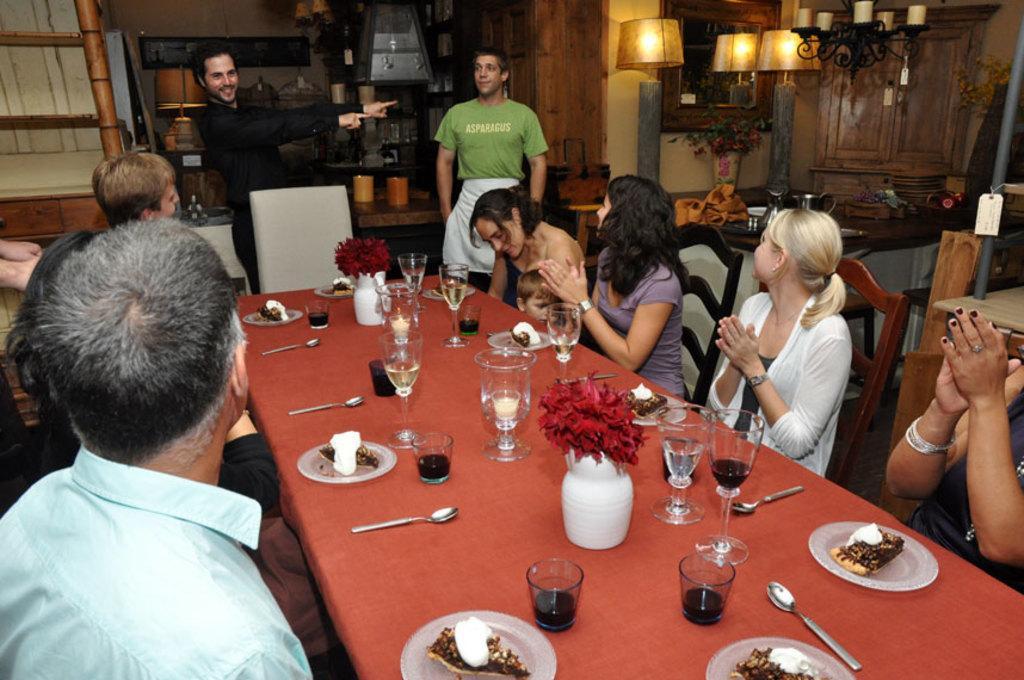How would you summarize this image in a sentence or two? As we can see in the image there are few people sitting on chairs and there is a lamp, chandelier and a table. On table there are glasses, plates, spoons and flower flask 